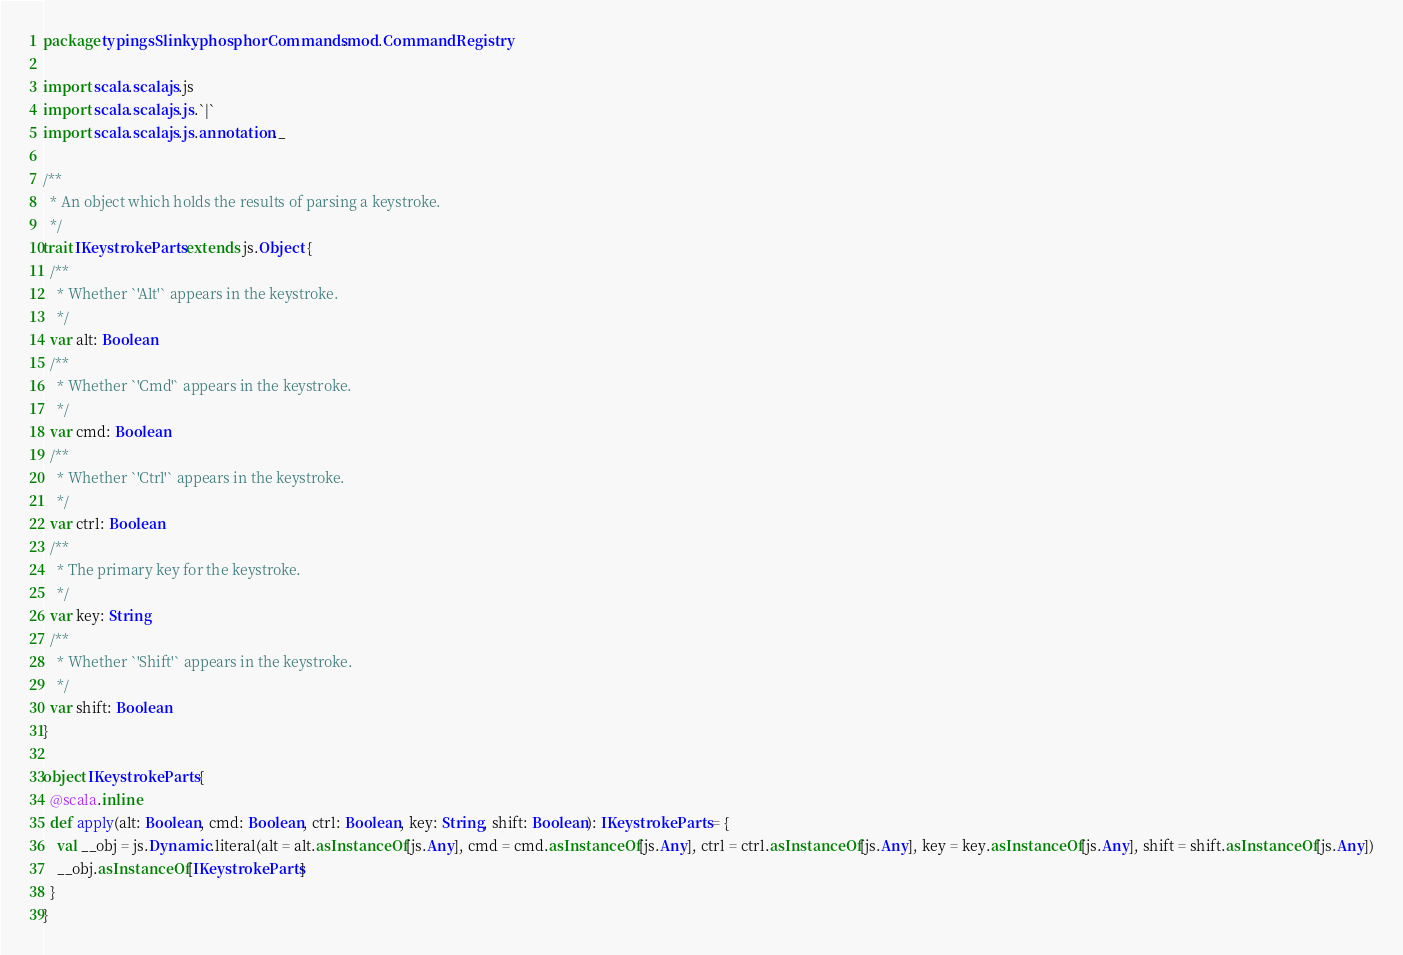<code> <loc_0><loc_0><loc_500><loc_500><_Scala_>package typingsSlinky.phosphorCommands.mod.CommandRegistry

import scala.scalajs.js
import scala.scalajs.js.`|`
import scala.scalajs.js.annotation._

/**
  * An object which holds the results of parsing a keystroke.
  */
trait IKeystrokeParts extends js.Object {
  /**
    * Whether `'Alt'` appears in the keystroke.
    */
  var alt: Boolean
  /**
    * Whether `'Cmd'` appears in the keystroke.
    */
  var cmd: Boolean
  /**
    * Whether `'Ctrl'` appears in the keystroke.
    */
  var ctrl: Boolean
  /**
    * The primary key for the keystroke.
    */
  var key: String
  /**
    * Whether `'Shift'` appears in the keystroke.
    */
  var shift: Boolean
}

object IKeystrokeParts {
  @scala.inline
  def apply(alt: Boolean, cmd: Boolean, ctrl: Boolean, key: String, shift: Boolean): IKeystrokeParts = {
    val __obj = js.Dynamic.literal(alt = alt.asInstanceOf[js.Any], cmd = cmd.asInstanceOf[js.Any], ctrl = ctrl.asInstanceOf[js.Any], key = key.asInstanceOf[js.Any], shift = shift.asInstanceOf[js.Any])
    __obj.asInstanceOf[IKeystrokeParts]
  }
}

</code> 